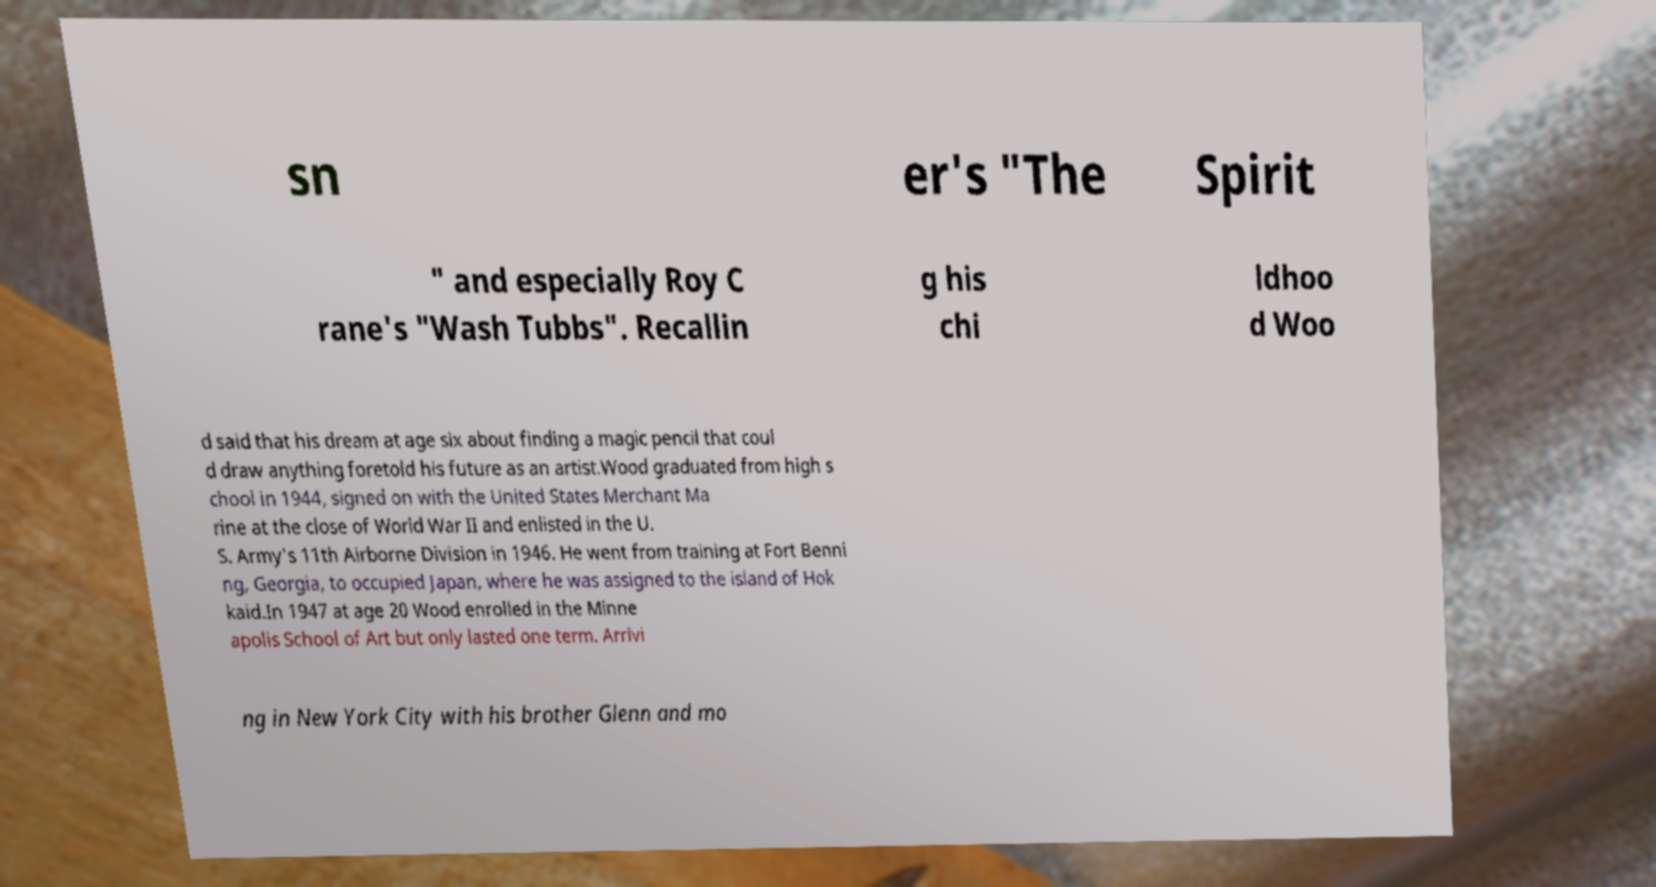I need the written content from this picture converted into text. Can you do that? sn er's "The Spirit " and especially Roy C rane's "Wash Tubbs". Recallin g his chi ldhoo d Woo d said that his dream at age six about finding a magic pencil that coul d draw anything foretold his future as an artist.Wood graduated from high s chool in 1944, signed on with the United States Merchant Ma rine at the close of World War II and enlisted in the U. S. Army's 11th Airborne Division in 1946. He went from training at Fort Benni ng, Georgia, to occupied Japan, where he was assigned to the island of Hok kaid.In 1947 at age 20 Wood enrolled in the Minne apolis School of Art but only lasted one term. Arrivi ng in New York City with his brother Glenn and mo 